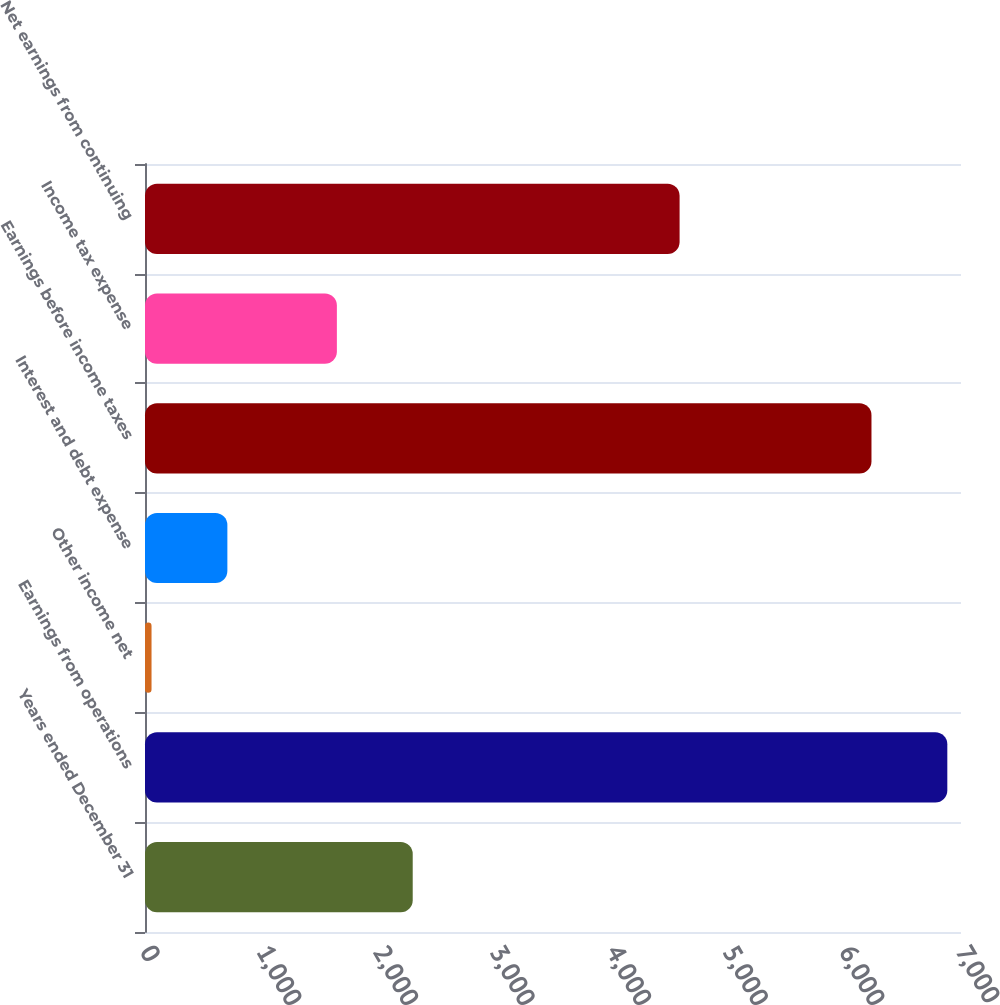Convert chart. <chart><loc_0><loc_0><loc_500><loc_500><bar_chart><fcel>Years ended December 31<fcel>Earnings from operations<fcel>Other income net<fcel>Interest and debt expense<fcel>Earnings before income taxes<fcel>Income tax expense<fcel>Net earnings from continuing<nl><fcel>2296.6<fcel>6882.6<fcel>56<fcel>706.6<fcel>6232<fcel>1646<fcel>4586<nl></chart> 